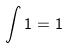<formula> <loc_0><loc_0><loc_500><loc_500>\int 1 = 1</formula> 